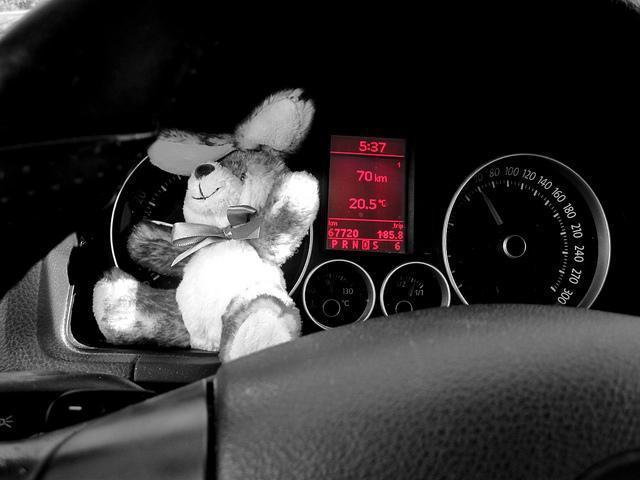How many people are standing in the truck?
Give a very brief answer. 0. 